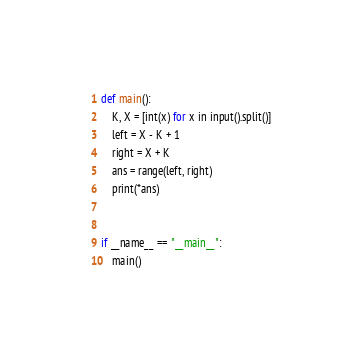<code> <loc_0><loc_0><loc_500><loc_500><_Python_>
def main():
    K, X = [int(x) for x in input().split()]
    left = X - K + 1
    right = X + K
    ans = range(left, right)
    print(*ans)


if __name__ == "__main__":
    main()
</code> 